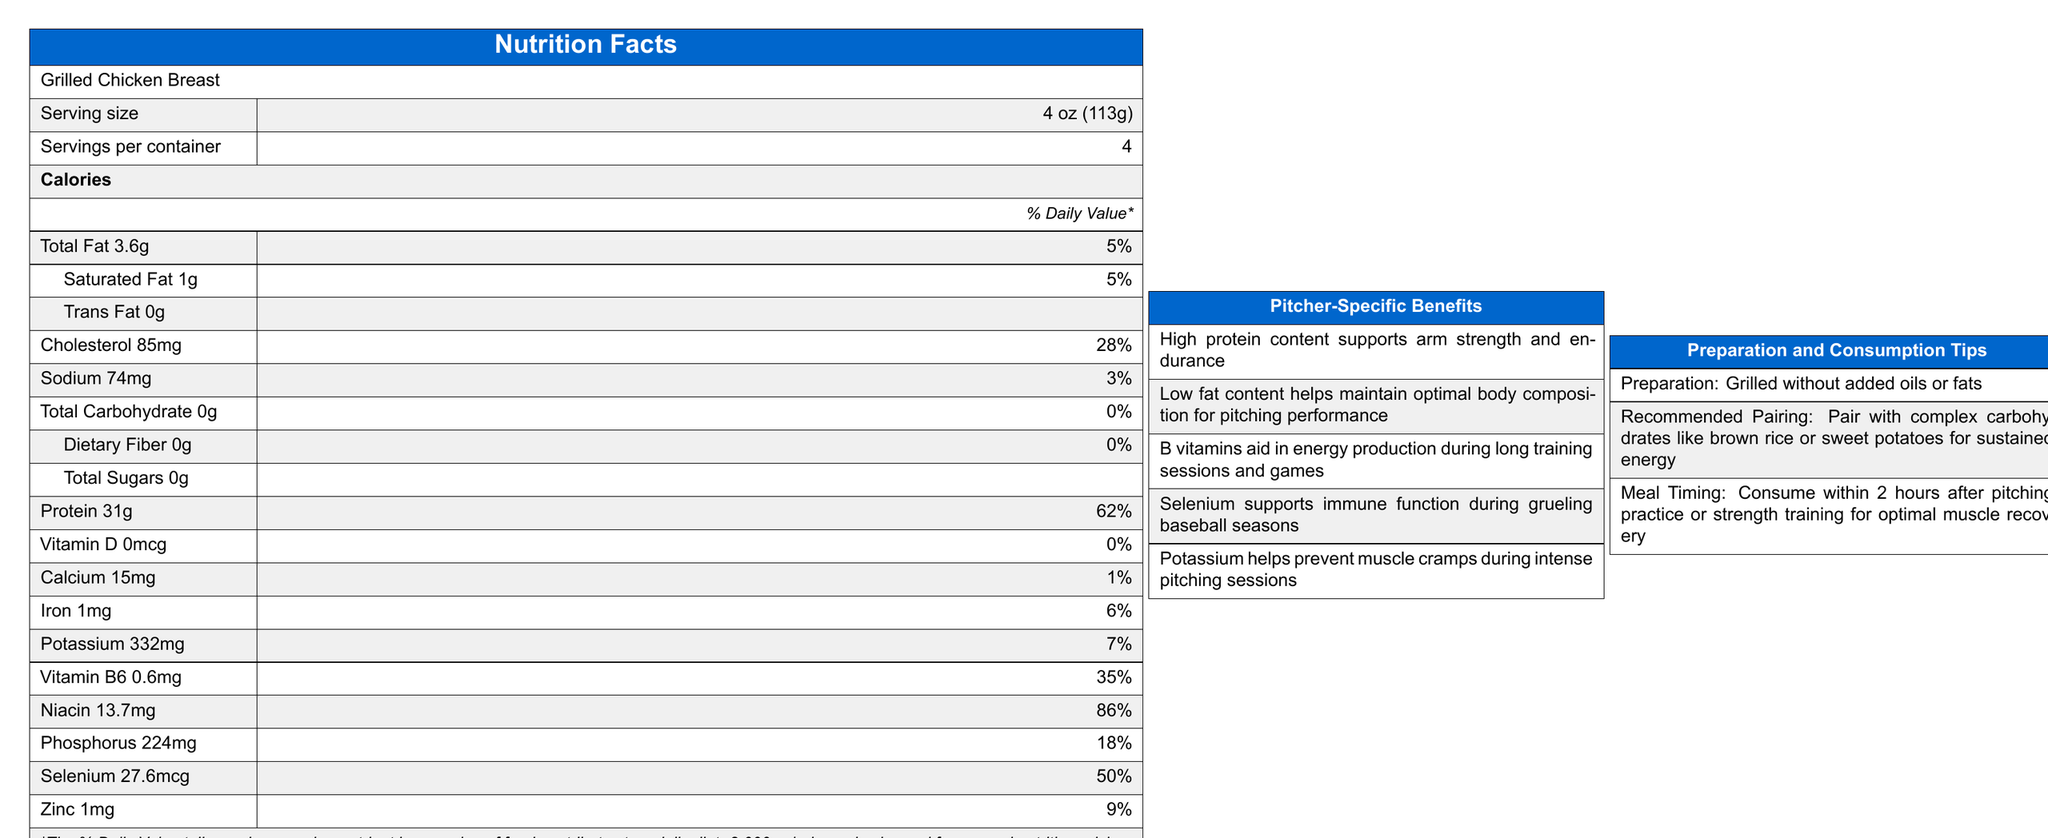What is the serving size of the Grilled Chicken Breast? The serving size is listed at the top of the Nutrition Facts label.
Answer: 4 oz (113g) How many calories are in one serving of Grilled Chicken Breast? The calories per serving are prominently listed under the serving size and servings per container.
Answer: 165 What is the total protein content in one serving of the Grilled Chicken Breast? The total protein content is listed in the Nutrition Facts as 31g for one serving.
Answer: 31g What percentage of the Daily Value is the protein content? The percentage of the Daily Value for protein is given as 62% on the Nutrition Facts label.
Answer: 62% What mineral helps prevent muscle cramps during intense pitching sessions? The Pitcher-Specific Benefits section mentions that potassium helps prevent muscle cramps.
Answer: Potassium Which of the following vitamins is present in the highest amount per serving? A. Vitamin D B. Vitamin B6 C. Niacin The Nutrition Facts label lists Niacin at 13.7mg (86% Daily Value), Vitamin B6 at 0.6mg (35% Daily Value), and Vitamin D at 0mcg (0% Daily Value).
Answer: C. Niacin What is the preparation method for Grilled Chicken Breast? A. Fried B. Baked C. Grilled The document states that the Grilled Chicken Breast is prepared by grilling without added oils or fats.
Answer: C. Grilled Is the Grilled Chicken Breast a good source of dietary fiber? The total dietary fiber content is listed as 0g, which is 0% of the Daily Value.
Answer: No Does the document provide a recommended meal timing for consumption after pitching practice? The Preparation and Consumption Tips section recommends consuming the meal within 2 hours after pitching practice or strength training.
Answer: Yes Summarize the main benefits of the Grilled Chicken Breast for pitchers. The main benefits section lists these key points, which are specifically useful for pitchers.
Answer: High protein content supports arm strength and endurance. Low fat content helps maintain optimal body composition. B vitamins aid in energy production. Selenium supports immune function. Potassium prevents muscle cramps. How does potassium in the chicken breast support pitchers? The document specifically mentions that potassium helps prevent muscle cramps during intense pitching sessions.
Answer: Prevents muscle cramps What is the total fat content in one serving? The Nutrition Facts label lists the total fat as 3.6g per serving.
Answer: 3.6g How much sodium is in one serving? The sodium content is listed as 74mg per serving.
Answer: 74mg Which mineral listed under Pitcher-Specific Benefits supports immune function? The Pitcher-Specific Benefits section mentions selenium supports immune function during grueling baseball seasons.
Answer: Selenium Can you determine the cost per container of the Grilled Chicken Breast from the document? The document does not provide any information about the cost per container.
Answer: Cannot be determined 